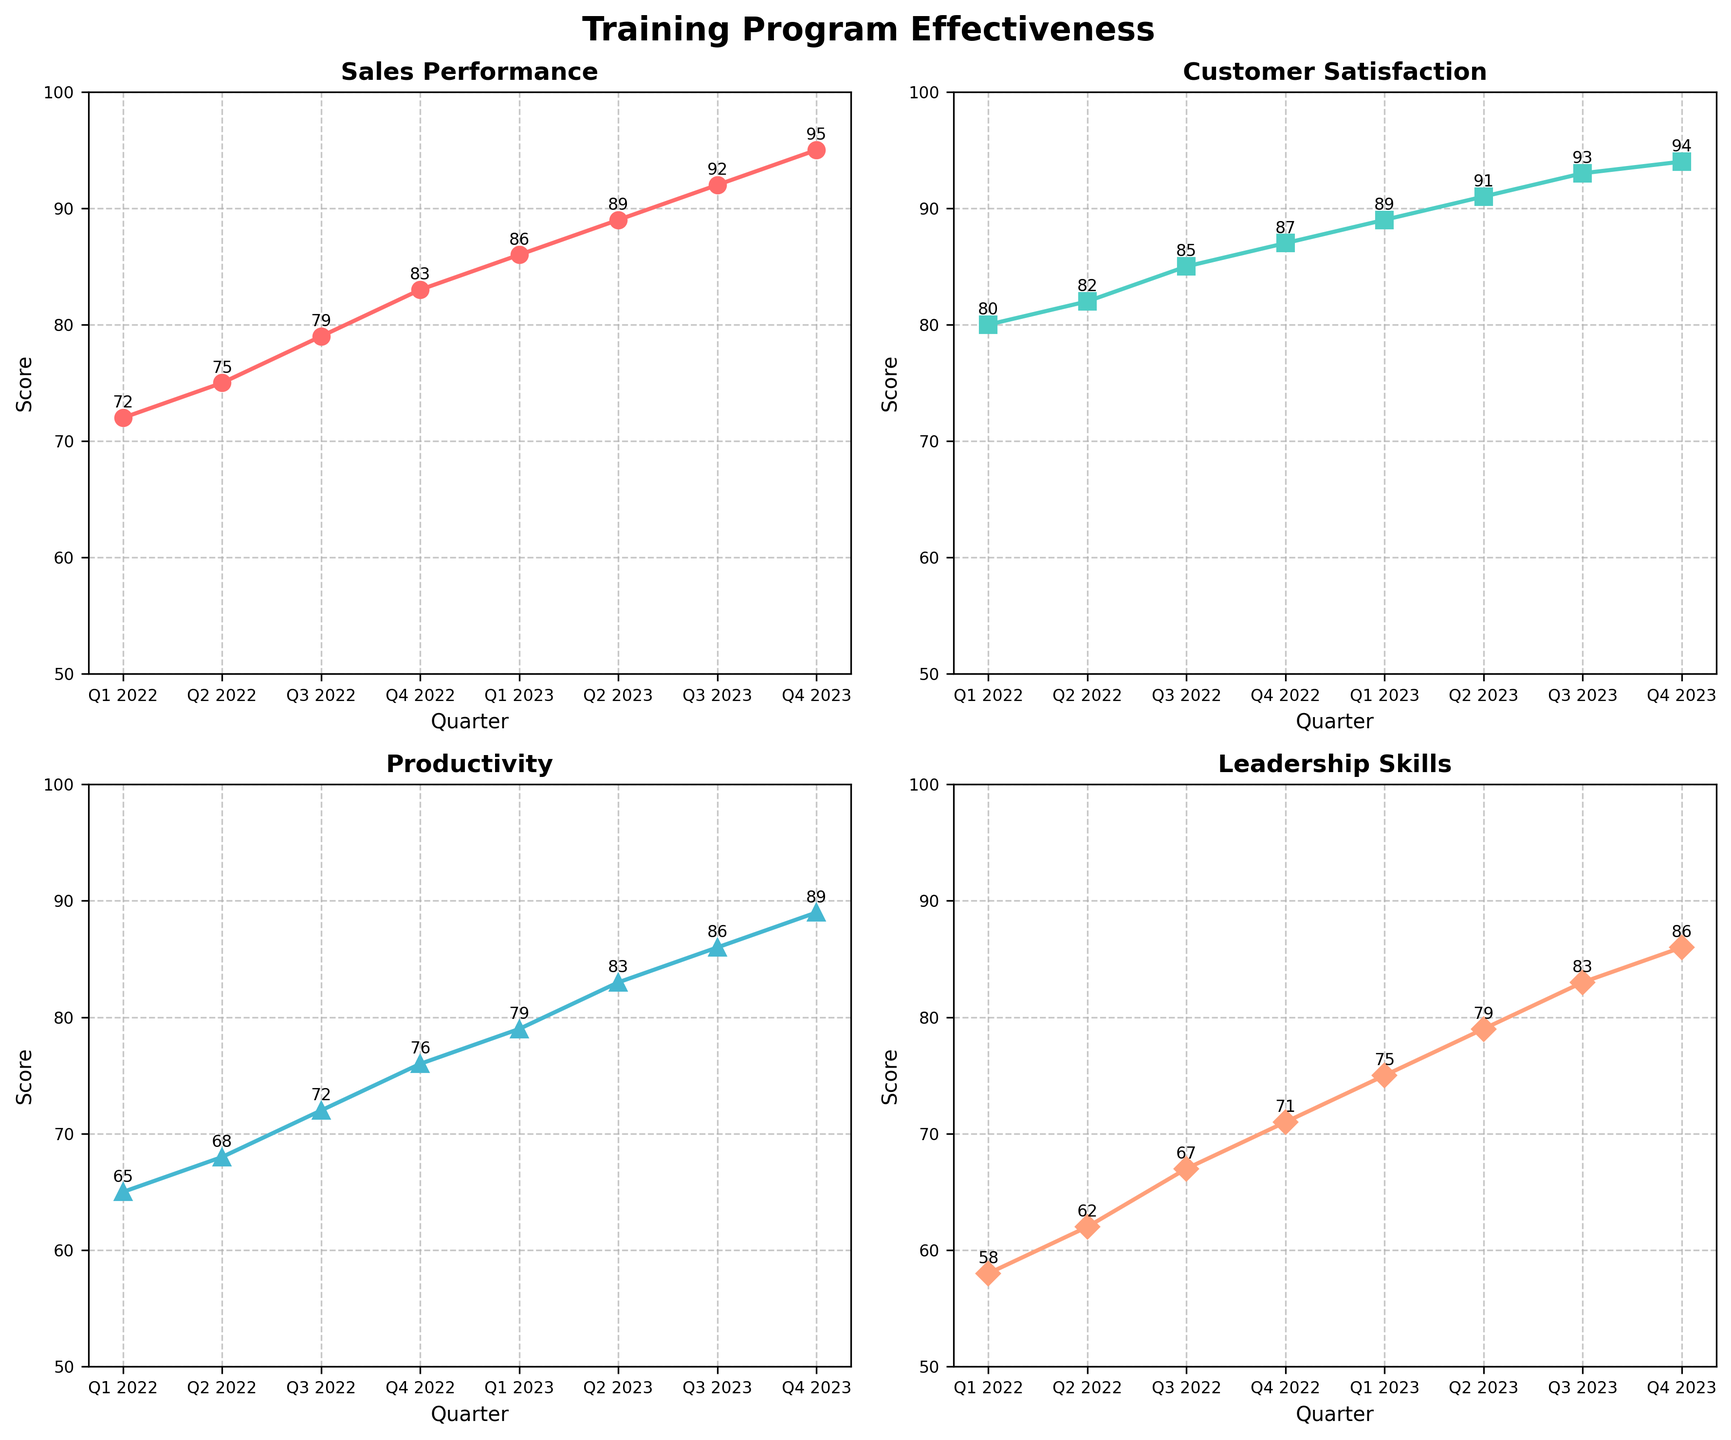How many quarters are plotted on each subplot? There are four subplots, each showing data over several quarters. Counting the data points, we see data for each quarter from Q1 2022 to Q4 2023, which totals 8 quarters.
Answer: 8 What is the highest score achieved in "Sales Performance"? By examining the "Sales Performance" subplot, the highest data point (score) is 95, which corresponds to Q4 2023.
Answer: 95 Compare the score trends for "Customer Satisfaction" and "Productivity". Do they follow a similar pattern? Both "Customer Satisfaction" and "Productivity" subplots show ascending trends; however, "Customer Satisfaction" scores start higher and rise to a smaller extent compared to "Productivity". Despite the difference in initial values and the magnitude of increase, both metrics consistently improve over time.
Answer: Yes, similar pattern What is the average score for "Leadership Skills" across all quarters? Adding all "Leadership Skills" scores: 58 + 62 + 67 + 71 + 75 + 79 + 83 + 86 = 581. Dividing by the number of quarters (8), the average is 581 / 8 = 72.625.
Answer: 72.625 Between Q3 2022 and Q3 2023, which metric saw the largest improvement? Calculate the improvement for each metric: 
- Sales Performance: 92 - 79 = 13
- Customer Satisfaction: 93 - 85 = 8
- Productivity: 86 - 72 = 14
- Leadership Skills: 83 - 67 = 16
The largest improvement occurred in "Leadership Skills" with an increase of 16 points.
Answer: Leadership Skills What quintruple plot title encapsulates the data's overall theme? All subplots are titled “Training Program Effectiveness”, which highlights the central theme of the data visualization: analyzing the effectiveness of a training program's impact on various metrics.
Answer: Training Program Effectiveness Which quarter demonstrates the highest "Customer Satisfaction" score and what is that value? In the "Customer Satisfaction" subplot, Q4 2023 exhibits the highest score, which is 94.
Answer: Q4 2023, 94 How did "Productivity" change from Q2 2022 to Q1 2023? In Q2 2022, the "Productivity" score is 68. In Q1 2023, it increases to 79. The change is computed as 79 - 68 = 11.
Answer: Increased by 11 In which quarter did "Sales Performance" score first exceed 90? By examining the "Sales Performance" subplot, the score first exceeds 90 in Q3 2023, where it hits 92.
Answer: Q3 2023 